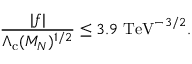Convert formula to latex. <formula><loc_0><loc_0><loc_500><loc_500>\frac { | f | } { \Lambda _ { c } ( M _ { N } ) ^ { 1 / 2 } } \leq 3 . 9 \, T e V ^ { - 3 / 2 } .</formula> 